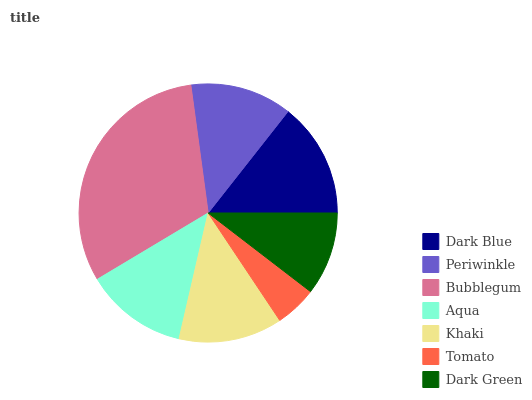Is Tomato the minimum?
Answer yes or no. Yes. Is Bubblegum the maximum?
Answer yes or no. Yes. Is Periwinkle the minimum?
Answer yes or no. No. Is Periwinkle the maximum?
Answer yes or no. No. Is Dark Blue greater than Periwinkle?
Answer yes or no. Yes. Is Periwinkle less than Dark Blue?
Answer yes or no. Yes. Is Periwinkle greater than Dark Blue?
Answer yes or no. No. Is Dark Blue less than Periwinkle?
Answer yes or no. No. Is Aqua the high median?
Answer yes or no. Yes. Is Aqua the low median?
Answer yes or no. Yes. Is Dark Blue the high median?
Answer yes or no. No. Is Dark Blue the low median?
Answer yes or no. No. 